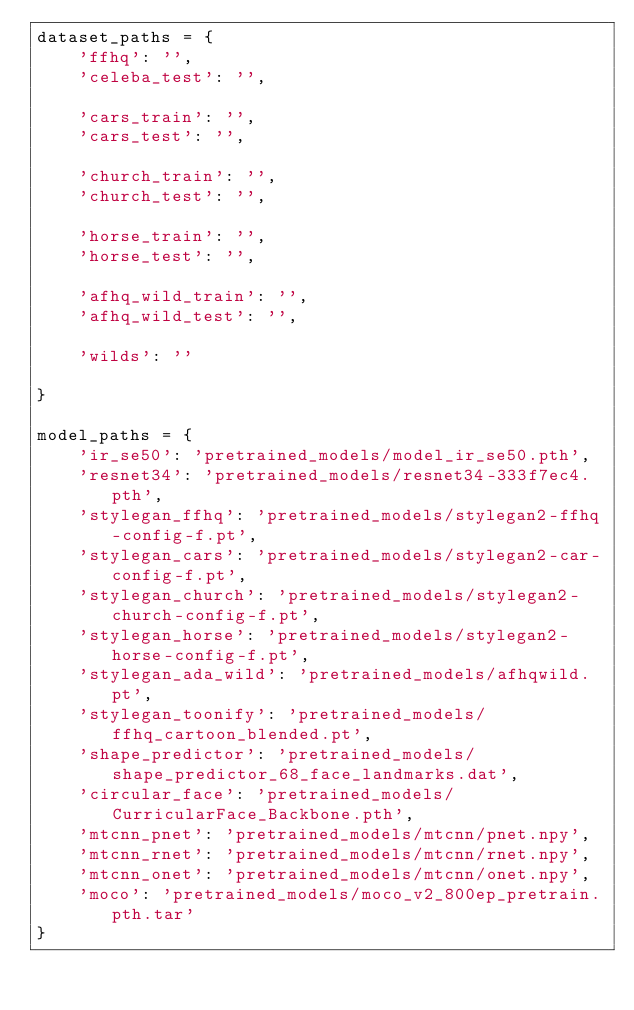Convert code to text. <code><loc_0><loc_0><loc_500><loc_500><_Python_>dataset_paths = {
	'ffhq': '',
	'celeba_test': '',

	'cars_train': '',
	'cars_test': '',

	'church_train': '',
	'church_test': '',

	'horse_train': '',
	'horse_test': '',

	'afhq_wild_train': '',
	'afhq_wild_test': '',

	'wilds': ''

}

model_paths = {
	'ir_se50': 'pretrained_models/model_ir_se50.pth',
	'resnet34': 'pretrained_models/resnet34-333f7ec4.pth',
	'stylegan_ffhq': 'pretrained_models/stylegan2-ffhq-config-f.pt',
	'stylegan_cars': 'pretrained_models/stylegan2-car-config-f.pt',
	'stylegan_church': 'pretrained_models/stylegan2-church-config-f.pt',
	'stylegan_horse': 'pretrained_models/stylegan2-horse-config-f.pt',
	'stylegan_ada_wild': 'pretrained_models/afhqwild.pt',
	'stylegan_toonify': 'pretrained_models/ffhq_cartoon_blended.pt',
	'shape_predictor': 'pretrained_models/shape_predictor_68_face_landmarks.dat',
	'circular_face': 'pretrained_models/CurricularFace_Backbone.pth',
	'mtcnn_pnet': 'pretrained_models/mtcnn/pnet.npy',
	'mtcnn_rnet': 'pretrained_models/mtcnn/rnet.npy',
	'mtcnn_onet': 'pretrained_models/mtcnn/onet.npy',
	'moco': 'pretrained_models/moco_v2_800ep_pretrain.pth.tar'
}
</code> 